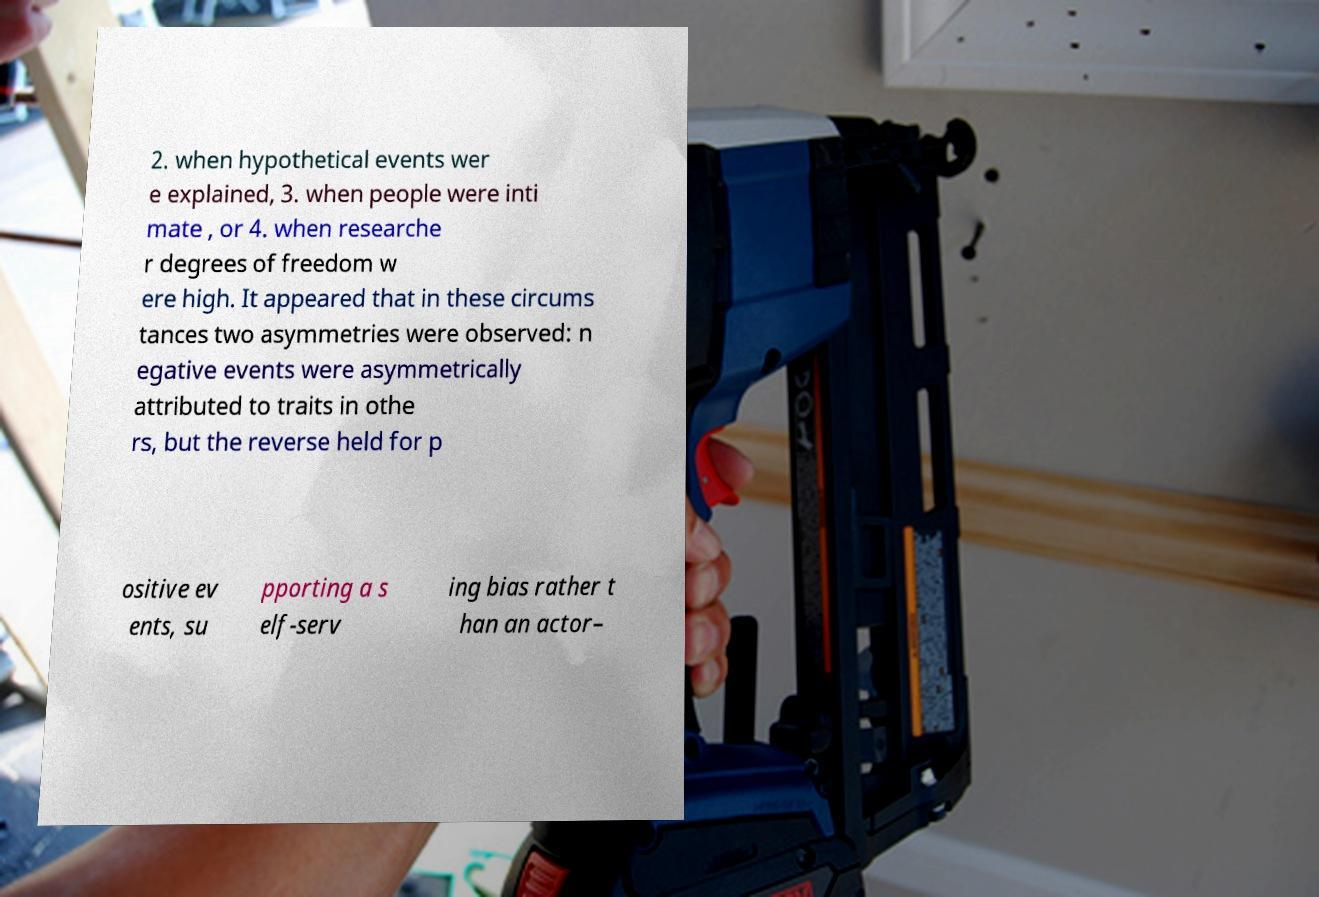Could you extract and type out the text from this image? 2. when hypothetical events wer e explained, 3. when people were inti mate , or 4. when researche r degrees of freedom w ere high. It appeared that in these circums tances two asymmetries were observed: n egative events were asymmetrically attributed to traits in othe rs, but the reverse held for p ositive ev ents, su pporting a s elf-serv ing bias rather t han an actor– 